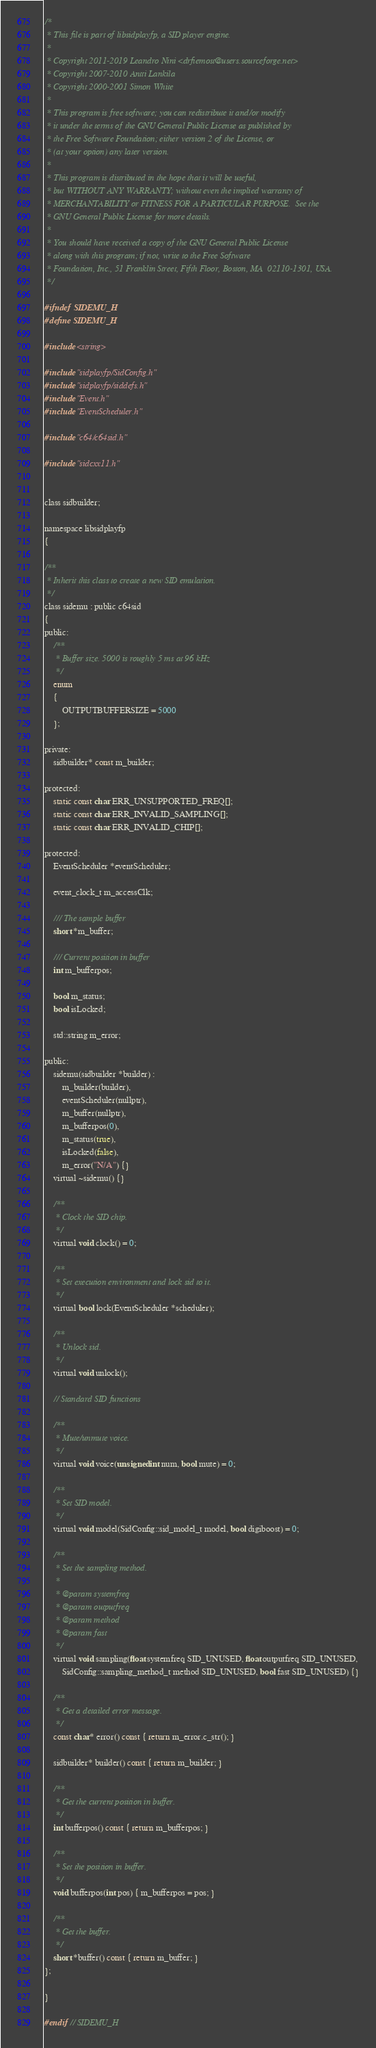Convert code to text. <code><loc_0><loc_0><loc_500><loc_500><_C_>/*
 * This file is part of libsidplayfp, a SID player engine.
 *
 * Copyright 2011-2019 Leandro Nini <drfiemost@users.sourceforge.net>
 * Copyright 2007-2010 Antti Lankila
 * Copyright 2000-2001 Simon White
 *
 * This program is free software; you can redistribute it and/or modify
 * it under the terms of the GNU General Public License as published by
 * the Free Software Foundation; either version 2 of the License, or
 * (at your option) any later version.
 *
 * This program is distributed in the hope that it will be useful,
 * but WITHOUT ANY WARRANTY; without even the implied warranty of
 * MERCHANTABILITY or FITNESS FOR A PARTICULAR PURPOSE.  See the
 * GNU General Public License for more details.
 *
 * You should have received a copy of the GNU General Public License
 * along with this program; if not, write to the Free Software
 * Foundation, Inc., 51 Franklin Street, Fifth Floor, Boston, MA  02110-1301, USA.
 */

#ifndef SIDEMU_H
#define SIDEMU_H

#include <string>

#include "sidplayfp/SidConfig.h"
#include "sidplayfp/siddefs.h"
#include "Event.h"
#include "EventScheduler.h"

#include "c64/c64sid.h"

#include "sidcxx11.h"


class sidbuilder;

namespace libsidplayfp
{

/**
 * Inherit this class to create a new SID emulation.
 */
class sidemu : public c64sid
{
public:
    /**
     * Buffer size. 5000 is roughly 5 ms at 96 kHz
     */
    enum
    {
        OUTPUTBUFFERSIZE = 5000
    };

private:
    sidbuilder* const m_builder;

protected:
    static const char ERR_UNSUPPORTED_FREQ[];
    static const char ERR_INVALID_SAMPLING[];
    static const char ERR_INVALID_CHIP[];

protected:
    EventScheduler *eventScheduler;

    event_clock_t m_accessClk;

    /// The sample buffer
    short *m_buffer;

    /// Current position in buffer
    int m_bufferpos;

    bool m_status;
    bool isLocked;

    std::string m_error;

public:
    sidemu(sidbuilder *builder) :
        m_builder(builder),
        eventScheduler(nullptr),
        m_buffer(nullptr),
        m_bufferpos(0),
        m_status(true),
        isLocked(false),
        m_error("N/A") {}
    virtual ~sidemu() {}

    /**
     * Clock the SID chip.
     */
    virtual void clock() = 0;

    /**
     * Set execution environment and lock sid to it.
     */
    virtual bool lock(EventScheduler *scheduler);

    /**
     * Unlock sid.
     */
    virtual void unlock();

    // Standard SID functions
    
    /**
     * Mute/unmute voice.
     */
    virtual void voice(unsigned int num, bool mute) = 0;

    /**
     * Set SID model.
     */
    virtual void model(SidConfig::sid_model_t model, bool digiboost) = 0;

    /**
     * Set the sampling method.
     *
     * @param systemfreq
     * @param outputfreq
     * @param method
     * @param fast
     */
    virtual void sampling(float systemfreq SID_UNUSED, float outputfreq SID_UNUSED,
        SidConfig::sampling_method_t method SID_UNUSED, bool fast SID_UNUSED) {}

    /**
     * Get a detailed error message.
     */
    const char* error() const { return m_error.c_str(); }

    sidbuilder* builder() const { return m_builder; }

    /**
     * Get the current position in buffer.
     */
    int bufferpos() const { return m_bufferpos; }

    /**
     * Set the position in buffer.
     */
    void bufferpos(int pos) { m_bufferpos = pos; }

    /**
     * Get the buffer.
     */
    short *buffer() const { return m_buffer; }
};

}

#endif // SIDEMU_H
</code> 